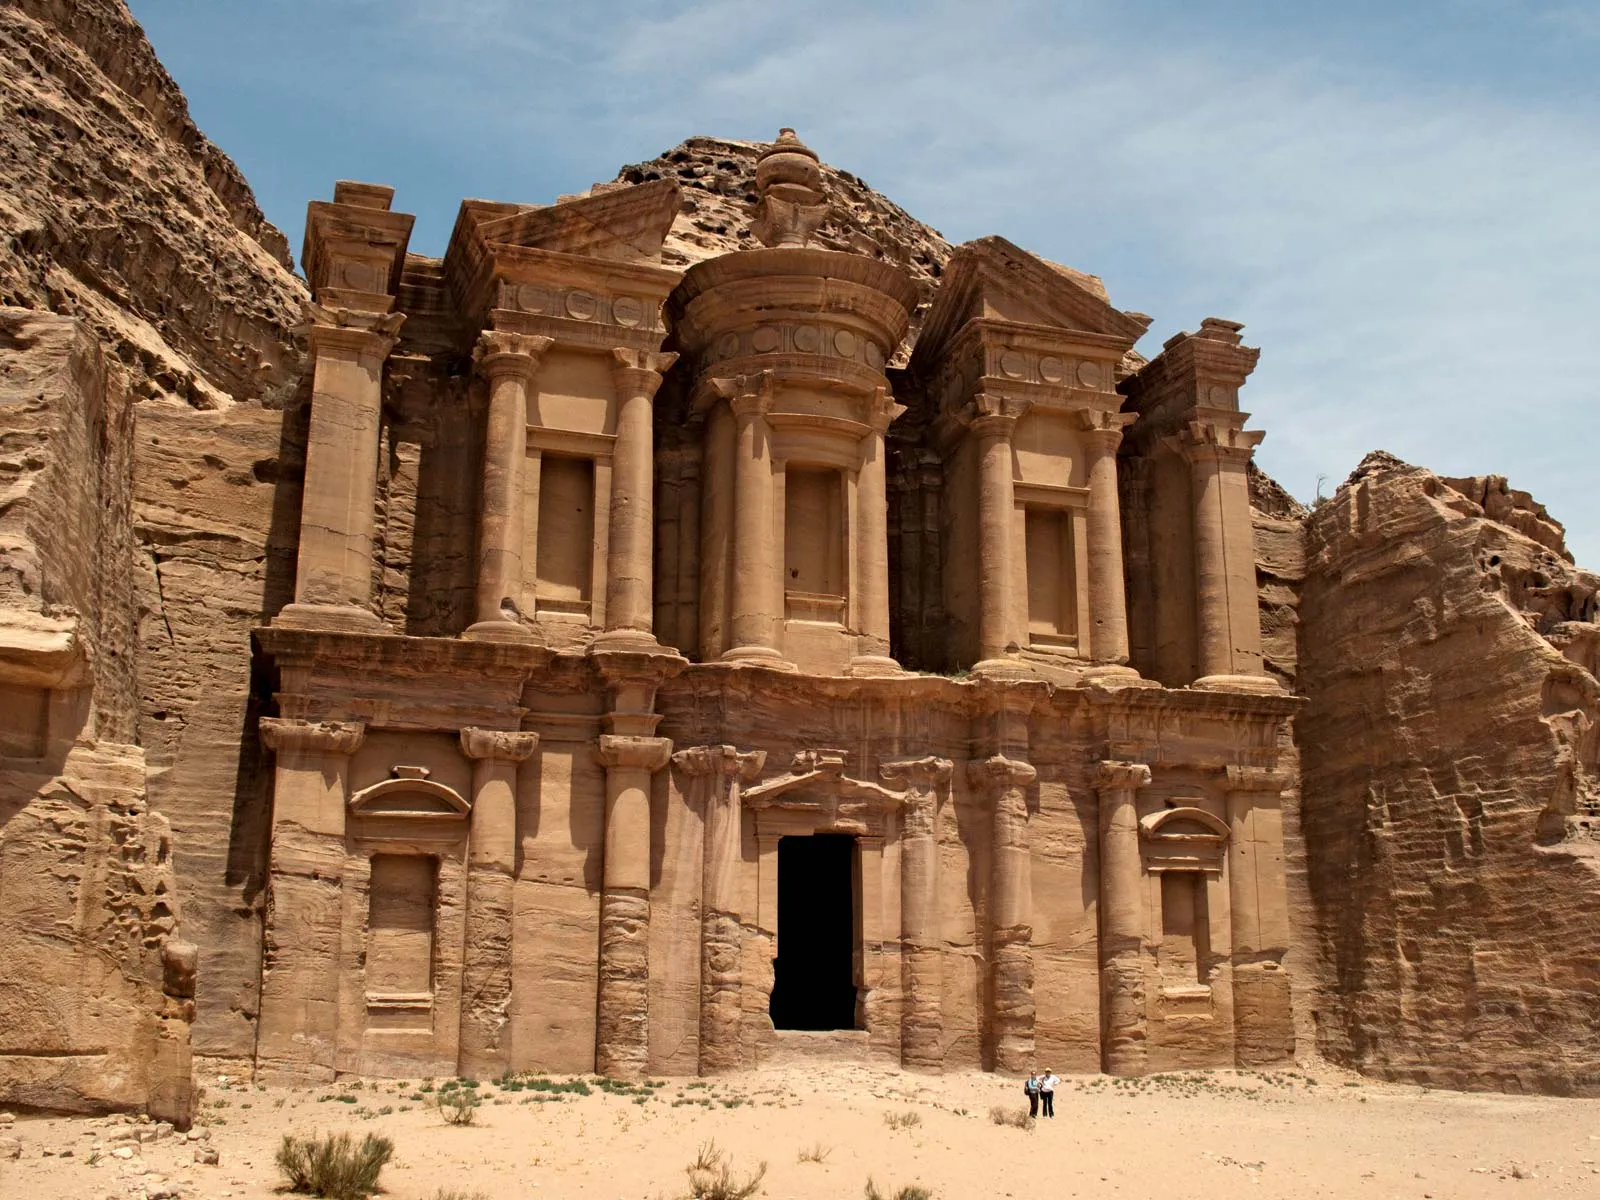Can you describe the main features of this image for me? The image beautifully showcases the ancient city of Petra, specifically highlighting the Monastery, also known as Ad Deir. This monumental edifice, carved meticulously into the sandstone cliff, exemplifies the extraordinary craftsmanship of the Nabateans. The structure’s facade, despite the passage of time, still retains its intricate and majestic carvings, giving us a glimpse into its ancient splendor. The warm hues of the sandstone harmonize with the sandy ground below, while the expansive blue sky provides a striking contrast, amplifying the overall grandeur of the scene. In the lower part of the image, two figures can be seen standing, subtly emphasizing the immense scale of the Monastery. The photo, taken from a distance, offers a comprehensive view that not only highlights the structure’s impressive architecture but also invites viewers to appreciate the rich historical and cultural heritage of this remarkable site. 